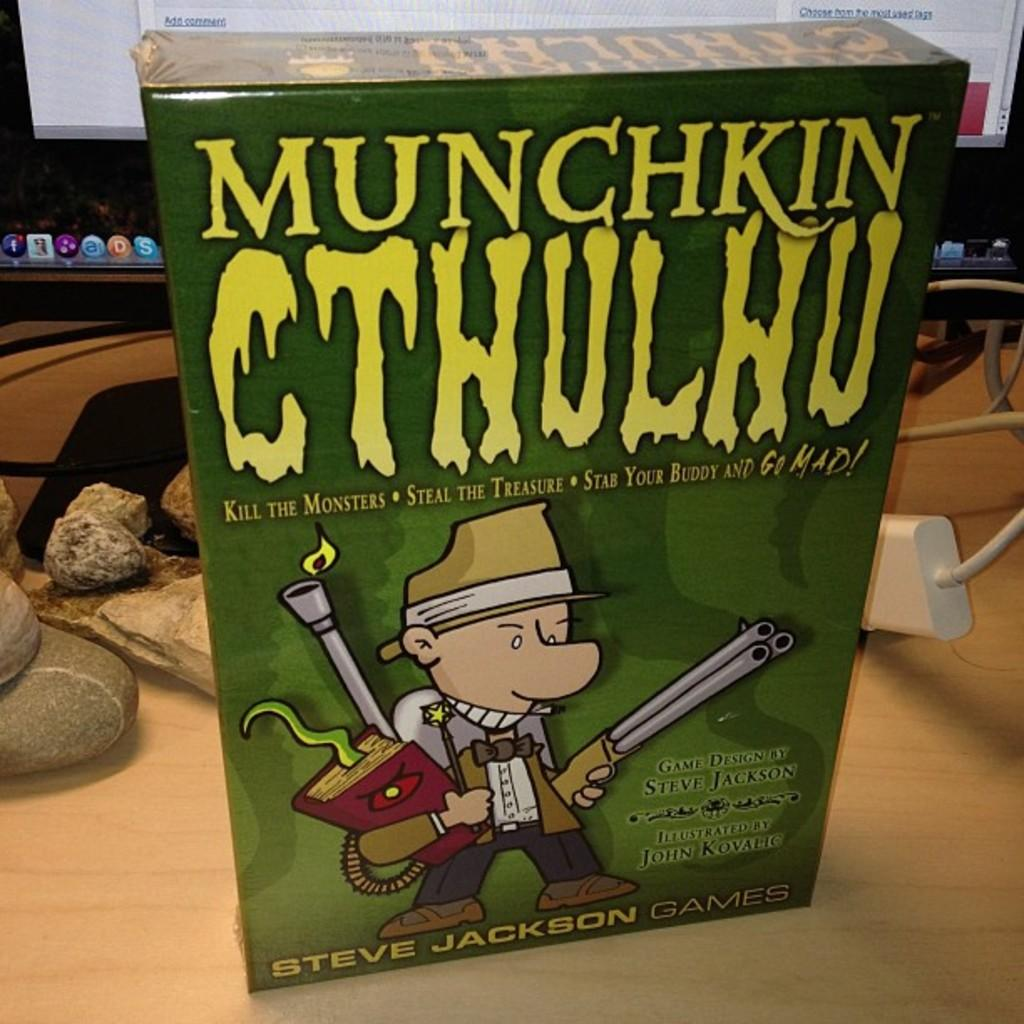<image>
Render a clear and concise summary of the photo. A game by Steve Jackson sits on a table in front of a computer monitor. 